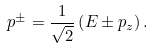Convert formula to latex. <formula><loc_0><loc_0><loc_500><loc_500>p ^ { \pm } = { \frac { 1 } { \sqrt { 2 } } } \left ( E \pm p _ { z } \right ) .</formula> 